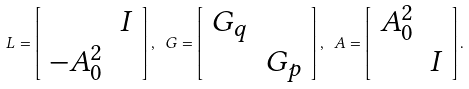<formula> <loc_0><loc_0><loc_500><loc_500>L = \left [ \begin{array} { c c } \ & I \\ - A _ { 0 } ^ { 2 } & \ \end{array} \right ] , \ G = \left [ \begin{array} { c c } G _ { q } & \ \\ \ & G _ { p } \end{array} \right ] , \ A = \left [ \begin{array} { c c } A ^ { 2 } _ { 0 } & \ \\ \ & I \end{array} \right ] .</formula> 